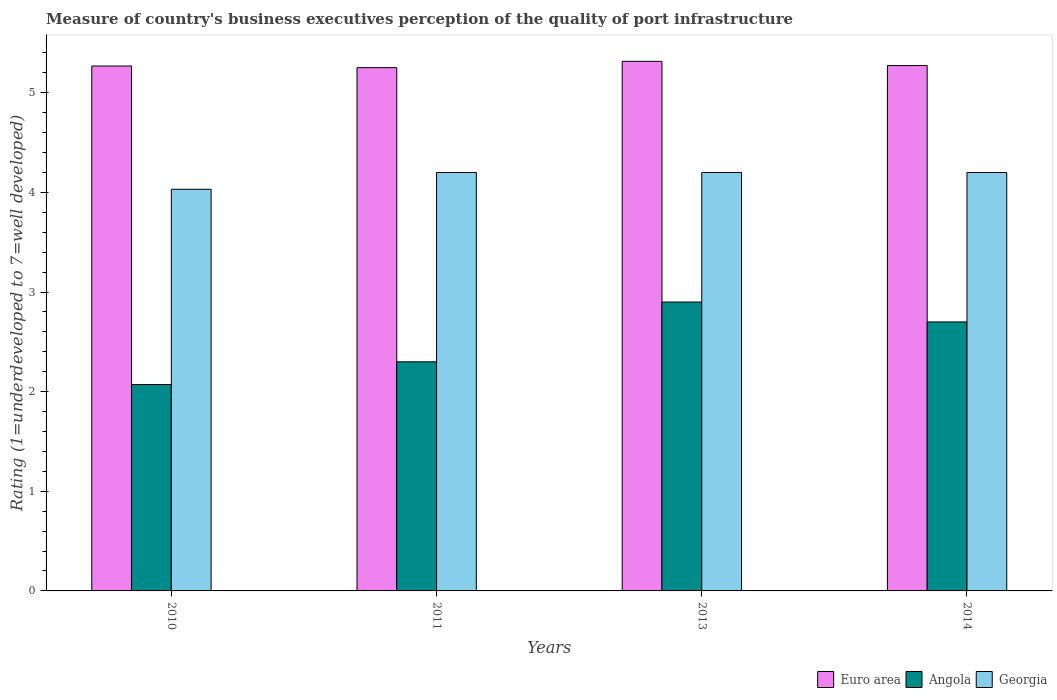How many different coloured bars are there?
Your answer should be very brief. 3. Are the number of bars per tick equal to the number of legend labels?
Provide a succinct answer. Yes. How many bars are there on the 4th tick from the left?
Your answer should be compact. 3. How many bars are there on the 4th tick from the right?
Offer a very short reply. 3. In how many cases, is the number of bars for a given year not equal to the number of legend labels?
Your answer should be very brief. 0. What is the ratings of the quality of port infrastructure in Euro area in 2014?
Offer a very short reply. 5.27. Across all years, what is the minimum ratings of the quality of port infrastructure in Georgia?
Ensure brevity in your answer.  4.03. In which year was the ratings of the quality of port infrastructure in Euro area maximum?
Offer a terse response. 2013. What is the total ratings of the quality of port infrastructure in Angola in the graph?
Make the answer very short. 9.97. What is the difference between the ratings of the quality of port infrastructure in Euro area in 2011 and the ratings of the quality of port infrastructure in Georgia in 2014?
Give a very brief answer. 1.05. What is the average ratings of the quality of port infrastructure in Georgia per year?
Keep it short and to the point. 4.16. In the year 2013, what is the difference between the ratings of the quality of port infrastructure in Angola and ratings of the quality of port infrastructure in Georgia?
Ensure brevity in your answer.  -1.3. What is the ratio of the ratings of the quality of port infrastructure in Euro area in 2013 to that in 2014?
Provide a short and direct response. 1.01. Is the ratings of the quality of port infrastructure in Georgia in 2011 less than that in 2013?
Provide a short and direct response. No. What is the difference between the highest and the second highest ratings of the quality of port infrastructure in Georgia?
Provide a short and direct response. 0. What is the difference between the highest and the lowest ratings of the quality of port infrastructure in Georgia?
Provide a succinct answer. 0.17. Is the sum of the ratings of the quality of port infrastructure in Euro area in 2010 and 2013 greater than the maximum ratings of the quality of port infrastructure in Georgia across all years?
Give a very brief answer. Yes. What does the 3rd bar from the left in 2014 represents?
Your answer should be very brief. Georgia. What does the 1st bar from the right in 2013 represents?
Ensure brevity in your answer.  Georgia. Are all the bars in the graph horizontal?
Provide a short and direct response. No. How many years are there in the graph?
Give a very brief answer. 4. Are the values on the major ticks of Y-axis written in scientific E-notation?
Ensure brevity in your answer.  No. How are the legend labels stacked?
Provide a short and direct response. Horizontal. What is the title of the graph?
Make the answer very short. Measure of country's business executives perception of the quality of port infrastructure. What is the label or title of the Y-axis?
Provide a short and direct response. Rating (1=underdeveloped to 7=well developed). What is the Rating (1=underdeveloped to 7=well developed) in Euro area in 2010?
Your response must be concise. 5.27. What is the Rating (1=underdeveloped to 7=well developed) of Angola in 2010?
Keep it short and to the point. 2.07. What is the Rating (1=underdeveloped to 7=well developed) in Georgia in 2010?
Provide a succinct answer. 4.03. What is the Rating (1=underdeveloped to 7=well developed) in Euro area in 2011?
Your response must be concise. 5.25. What is the Rating (1=underdeveloped to 7=well developed) in Angola in 2011?
Your response must be concise. 2.3. What is the Rating (1=underdeveloped to 7=well developed) in Georgia in 2011?
Your answer should be very brief. 4.2. What is the Rating (1=underdeveloped to 7=well developed) of Euro area in 2013?
Provide a succinct answer. 5.32. What is the Rating (1=underdeveloped to 7=well developed) of Euro area in 2014?
Keep it short and to the point. 5.27. What is the Rating (1=underdeveloped to 7=well developed) of Angola in 2014?
Provide a succinct answer. 2.7. What is the Rating (1=underdeveloped to 7=well developed) in Georgia in 2014?
Your answer should be compact. 4.2. Across all years, what is the maximum Rating (1=underdeveloped to 7=well developed) in Euro area?
Provide a succinct answer. 5.32. Across all years, what is the maximum Rating (1=underdeveloped to 7=well developed) in Angola?
Provide a short and direct response. 2.9. Across all years, what is the minimum Rating (1=underdeveloped to 7=well developed) in Euro area?
Your answer should be compact. 5.25. Across all years, what is the minimum Rating (1=underdeveloped to 7=well developed) of Angola?
Your answer should be very brief. 2.07. Across all years, what is the minimum Rating (1=underdeveloped to 7=well developed) of Georgia?
Your answer should be very brief. 4.03. What is the total Rating (1=underdeveloped to 7=well developed) in Euro area in the graph?
Make the answer very short. 21.11. What is the total Rating (1=underdeveloped to 7=well developed) in Angola in the graph?
Provide a short and direct response. 9.97. What is the total Rating (1=underdeveloped to 7=well developed) of Georgia in the graph?
Offer a very short reply. 16.63. What is the difference between the Rating (1=underdeveloped to 7=well developed) in Euro area in 2010 and that in 2011?
Offer a terse response. 0.02. What is the difference between the Rating (1=underdeveloped to 7=well developed) in Angola in 2010 and that in 2011?
Make the answer very short. -0.23. What is the difference between the Rating (1=underdeveloped to 7=well developed) in Georgia in 2010 and that in 2011?
Your response must be concise. -0.17. What is the difference between the Rating (1=underdeveloped to 7=well developed) of Euro area in 2010 and that in 2013?
Your answer should be compact. -0.05. What is the difference between the Rating (1=underdeveloped to 7=well developed) of Angola in 2010 and that in 2013?
Your response must be concise. -0.83. What is the difference between the Rating (1=underdeveloped to 7=well developed) in Georgia in 2010 and that in 2013?
Keep it short and to the point. -0.17. What is the difference between the Rating (1=underdeveloped to 7=well developed) of Euro area in 2010 and that in 2014?
Provide a short and direct response. -0. What is the difference between the Rating (1=underdeveloped to 7=well developed) of Angola in 2010 and that in 2014?
Give a very brief answer. -0.63. What is the difference between the Rating (1=underdeveloped to 7=well developed) in Georgia in 2010 and that in 2014?
Provide a succinct answer. -0.17. What is the difference between the Rating (1=underdeveloped to 7=well developed) in Euro area in 2011 and that in 2013?
Keep it short and to the point. -0.06. What is the difference between the Rating (1=underdeveloped to 7=well developed) in Euro area in 2011 and that in 2014?
Keep it short and to the point. -0.02. What is the difference between the Rating (1=underdeveloped to 7=well developed) in Euro area in 2013 and that in 2014?
Your response must be concise. 0.04. What is the difference between the Rating (1=underdeveloped to 7=well developed) of Georgia in 2013 and that in 2014?
Your answer should be compact. 0. What is the difference between the Rating (1=underdeveloped to 7=well developed) of Euro area in 2010 and the Rating (1=underdeveloped to 7=well developed) of Angola in 2011?
Your response must be concise. 2.97. What is the difference between the Rating (1=underdeveloped to 7=well developed) of Euro area in 2010 and the Rating (1=underdeveloped to 7=well developed) of Georgia in 2011?
Provide a succinct answer. 1.07. What is the difference between the Rating (1=underdeveloped to 7=well developed) of Angola in 2010 and the Rating (1=underdeveloped to 7=well developed) of Georgia in 2011?
Provide a succinct answer. -2.13. What is the difference between the Rating (1=underdeveloped to 7=well developed) in Euro area in 2010 and the Rating (1=underdeveloped to 7=well developed) in Angola in 2013?
Offer a terse response. 2.37. What is the difference between the Rating (1=underdeveloped to 7=well developed) of Euro area in 2010 and the Rating (1=underdeveloped to 7=well developed) of Georgia in 2013?
Your response must be concise. 1.07. What is the difference between the Rating (1=underdeveloped to 7=well developed) of Angola in 2010 and the Rating (1=underdeveloped to 7=well developed) of Georgia in 2013?
Offer a terse response. -2.13. What is the difference between the Rating (1=underdeveloped to 7=well developed) in Euro area in 2010 and the Rating (1=underdeveloped to 7=well developed) in Angola in 2014?
Ensure brevity in your answer.  2.57. What is the difference between the Rating (1=underdeveloped to 7=well developed) of Euro area in 2010 and the Rating (1=underdeveloped to 7=well developed) of Georgia in 2014?
Ensure brevity in your answer.  1.07. What is the difference between the Rating (1=underdeveloped to 7=well developed) in Angola in 2010 and the Rating (1=underdeveloped to 7=well developed) in Georgia in 2014?
Offer a terse response. -2.13. What is the difference between the Rating (1=underdeveloped to 7=well developed) of Euro area in 2011 and the Rating (1=underdeveloped to 7=well developed) of Angola in 2013?
Ensure brevity in your answer.  2.35. What is the difference between the Rating (1=underdeveloped to 7=well developed) of Euro area in 2011 and the Rating (1=underdeveloped to 7=well developed) of Georgia in 2013?
Provide a succinct answer. 1.05. What is the difference between the Rating (1=underdeveloped to 7=well developed) in Angola in 2011 and the Rating (1=underdeveloped to 7=well developed) in Georgia in 2013?
Provide a succinct answer. -1.9. What is the difference between the Rating (1=underdeveloped to 7=well developed) in Euro area in 2011 and the Rating (1=underdeveloped to 7=well developed) in Angola in 2014?
Make the answer very short. 2.55. What is the difference between the Rating (1=underdeveloped to 7=well developed) of Euro area in 2011 and the Rating (1=underdeveloped to 7=well developed) of Georgia in 2014?
Your answer should be very brief. 1.05. What is the difference between the Rating (1=underdeveloped to 7=well developed) in Euro area in 2013 and the Rating (1=underdeveloped to 7=well developed) in Angola in 2014?
Provide a short and direct response. 2.62. What is the difference between the Rating (1=underdeveloped to 7=well developed) in Euro area in 2013 and the Rating (1=underdeveloped to 7=well developed) in Georgia in 2014?
Make the answer very short. 1.12. What is the difference between the Rating (1=underdeveloped to 7=well developed) in Angola in 2013 and the Rating (1=underdeveloped to 7=well developed) in Georgia in 2014?
Keep it short and to the point. -1.3. What is the average Rating (1=underdeveloped to 7=well developed) of Euro area per year?
Your response must be concise. 5.28. What is the average Rating (1=underdeveloped to 7=well developed) of Angola per year?
Offer a very short reply. 2.49. What is the average Rating (1=underdeveloped to 7=well developed) in Georgia per year?
Ensure brevity in your answer.  4.16. In the year 2010, what is the difference between the Rating (1=underdeveloped to 7=well developed) of Euro area and Rating (1=underdeveloped to 7=well developed) of Angola?
Your answer should be compact. 3.2. In the year 2010, what is the difference between the Rating (1=underdeveloped to 7=well developed) of Euro area and Rating (1=underdeveloped to 7=well developed) of Georgia?
Your response must be concise. 1.24. In the year 2010, what is the difference between the Rating (1=underdeveloped to 7=well developed) of Angola and Rating (1=underdeveloped to 7=well developed) of Georgia?
Offer a very short reply. -1.96. In the year 2011, what is the difference between the Rating (1=underdeveloped to 7=well developed) in Euro area and Rating (1=underdeveloped to 7=well developed) in Angola?
Keep it short and to the point. 2.95. In the year 2011, what is the difference between the Rating (1=underdeveloped to 7=well developed) of Euro area and Rating (1=underdeveloped to 7=well developed) of Georgia?
Offer a very short reply. 1.05. In the year 2011, what is the difference between the Rating (1=underdeveloped to 7=well developed) of Angola and Rating (1=underdeveloped to 7=well developed) of Georgia?
Your response must be concise. -1.9. In the year 2013, what is the difference between the Rating (1=underdeveloped to 7=well developed) of Euro area and Rating (1=underdeveloped to 7=well developed) of Angola?
Provide a short and direct response. 2.42. In the year 2013, what is the difference between the Rating (1=underdeveloped to 7=well developed) of Euro area and Rating (1=underdeveloped to 7=well developed) of Georgia?
Your answer should be compact. 1.12. In the year 2013, what is the difference between the Rating (1=underdeveloped to 7=well developed) in Angola and Rating (1=underdeveloped to 7=well developed) in Georgia?
Make the answer very short. -1.3. In the year 2014, what is the difference between the Rating (1=underdeveloped to 7=well developed) in Euro area and Rating (1=underdeveloped to 7=well developed) in Angola?
Provide a succinct answer. 2.57. In the year 2014, what is the difference between the Rating (1=underdeveloped to 7=well developed) in Euro area and Rating (1=underdeveloped to 7=well developed) in Georgia?
Offer a terse response. 1.07. In the year 2014, what is the difference between the Rating (1=underdeveloped to 7=well developed) of Angola and Rating (1=underdeveloped to 7=well developed) of Georgia?
Offer a terse response. -1.5. What is the ratio of the Rating (1=underdeveloped to 7=well developed) in Euro area in 2010 to that in 2011?
Offer a terse response. 1. What is the ratio of the Rating (1=underdeveloped to 7=well developed) of Angola in 2010 to that in 2011?
Make the answer very short. 0.9. What is the ratio of the Rating (1=underdeveloped to 7=well developed) in Georgia in 2010 to that in 2011?
Offer a very short reply. 0.96. What is the ratio of the Rating (1=underdeveloped to 7=well developed) of Angola in 2010 to that in 2013?
Offer a very short reply. 0.71. What is the ratio of the Rating (1=underdeveloped to 7=well developed) of Georgia in 2010 to that in 2013?
Your answer should be compact. 0.96. What is the ratio of the Rating (1=underdeveloped to 7=well developed) of Euro area in 2010 to that in 2014?
Ensure brevity in your answer.  1. What is the ratio of the Rating (1=underdeveloped to 7=well developed) in Angola in 2010 to that in 2014?
Offer a terse response. 0.77. What is the ratio of the Rating (1=underdeveloped to 7=well developed) in Georgia in 2010 to that in 2014?
Ensure brevity in your answer.  0.96. What is the ratio of the Rating (1=underdeveloped to 7=well developed) of Angola in 2011 to that in 2013?
Offer a terse response. 0.79. What is the ratio of the Rating (1=underdeveloped to 7=well developed) of Euro area in 2011 to that in 2014?
Your answer should be compact. 1. What is the ratio of the Rating (1=underdeveloped to 7=well developed) in Angola in 2011 to that in 2014?
Offer a very short reply. 0.85. What is the ratio of the Rating (1=underdeveloped to 7=well developed) of Georgia in 2011 to that in 2014?
Your response must be concise. 1. What is the ratio of the Rating (1=underdeveloped to 7=well developed) in Angola in 2013 to that in 2014?
Ensure brevity in your answer.  1.07. What is the ratio of the Rating (1=underdeveloped to 7=well developed) of Georgia in 2013 to that in 2014?
Give a very brief answer. 1. What is the difference between the highest and the second highest Rating (1=underdeveloped to 7=well developed) of Euro area?
Provide a succinct answer. 0.04. What is the difference between the highest and the second highest Rating (1=underdeveloped to 7=well developed) of Georgia?
Keep it short and to the point. 0. What is the difference between the highest and the lowest Rating (1=underdeveloped to 7=well developed) of Euro area?
Your answer should be very brief. 0.06. What is the difference between the highest and the lowest Rating (1=underdeveloped to 7=well developed) of Angola?
Make the answer very short. 0.83. What is the difference between the highest and the lowest Rating (1=underdeveloped to 7=well developed) of Georgia?
Provide a succinct answer. 0.17. 